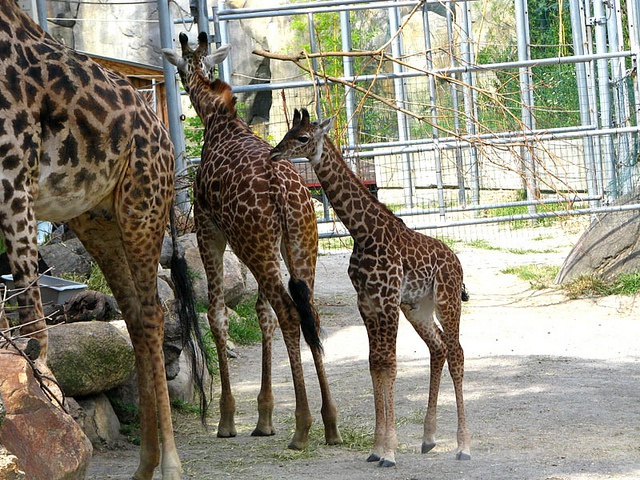Describe the objects in this image and their specific colors. I can see giraffe in maroon, black, and gray tones, giraffe in maroon, black, and gray tones, and giraffe in maroon, black, and gray tones in this image. 